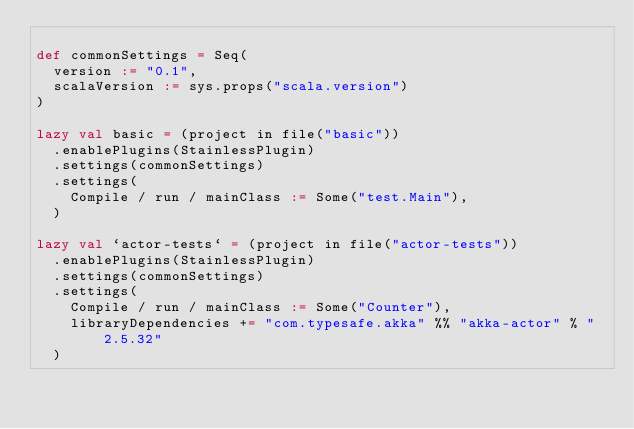Convert code to text. <code><loc_0><loc_0><loc_500><loc_500><_Scala_>
def commonSettings = Seq(
  version := "0.1",
  scalaVersion := sys.props("scala.version")
)

lazy val basic = (project in file("basic"))
  .enablePlugins(StainlessPlugin)
  .settings(commonSettings)
  .settings(
    Compile / run / mainClass := Some("test.Main"),
  )

lazy val `actor-tests` = (project in file("actor-tests"))
  .enablePlugins(StainlessPlugin)
  .settings(commonSettings)
  .settings(
    Compile / run / mainClass := Some("Counter"),
    libraryDependencies += "com.typesafe.akka" %% "akka-actor" % "2.5.32"
  )
</code> 